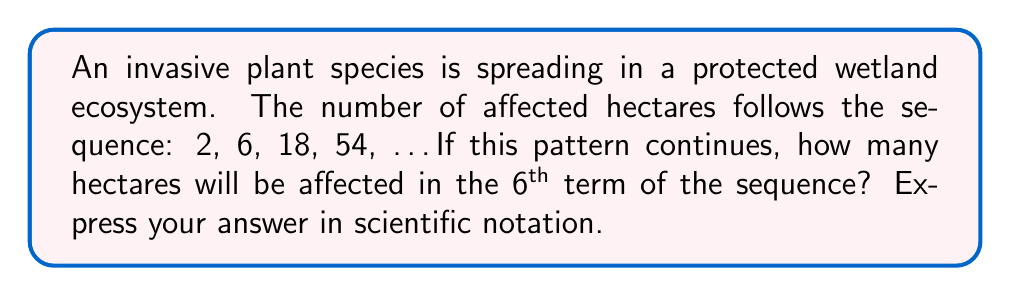Solve this math problem. Let's approach this step-by-step:

1) First, we need to identify the pattern in the sequence:
   2 → 6 → 18 → 54

2) To find the relationship between terms, let's divide each term by the previous one:
   6 ÷ 2 = 3
   18 ÷ 6 = 3
   54 ÷ 18 = 3

3) We can see that each term is 3 times the previous term. This is a geometric sequence with a common ratio of 3.

4) The general formula for a geometric sequence is:
   $$a_n = a_1 \cdot r^{n-1}$$
   where $a_n$ is the nth term, $a_1$ is the first term, r is the common ratio, and n is the term number.

5) In this case:
   $a_1 = 2$ (first term)
   $r = 3$ (common ratio)
   We need to find $a_6$ (6th term)

6) Plugging into the formula:
   $$a_6 = 2 \cdot 3^{6-1} = 2 \cdot 3^5$$

7) Calculate:
   $$2 \cdot 3^5 = 2 \cdot 243 = 486$$

8) Express in scientific notation:
   486 = 4.86 × 10^2

Therefore, in the 6th term, 4.86 × 10^2 hectares will be affected.
Answer: $4.86 \times 10^2$ 